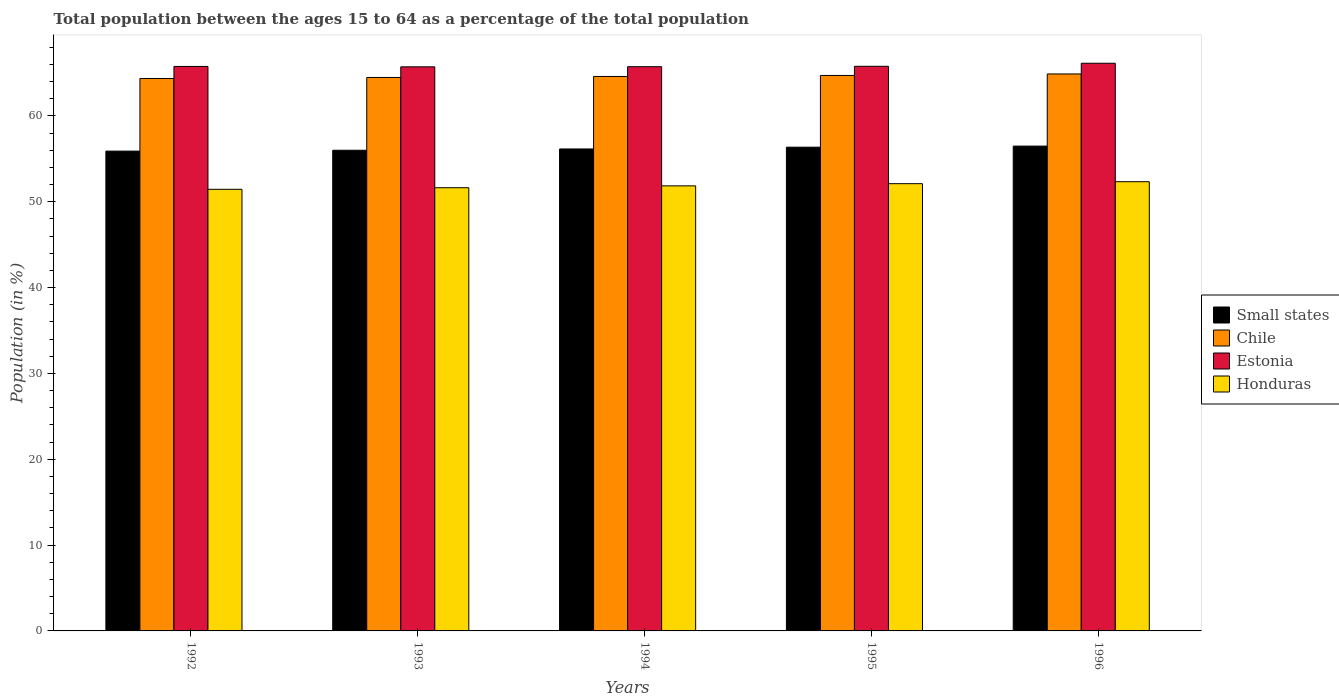How many different coloured bars are there?
Your answer should be compact. 4. How many bars are there on the 2nd tick from the left?
Your answer should be compact. 4. How many bars are there on the 2nd tick from the right?
Give a very brief answer. 4. In how many cases, is the number of bars for a given year not equal to the number of legend labels?
Your answer should be compact. 0. What is the percentage of the population ages 15 to 64 in Chile in 1996?
Make the answer very short. 64.89. Across all years, what is the maximum percentage of the population ages 15 to 64 in Estonia?
Offer a very short reply. 66.13. Across all years, what is the minimum percentage of the population ages 15 to 64 in Chile?
Provide a short and direct response. 64.36. In which year was the percentage of the population ages 15 to 64 in Chile maximum?
Your answer should be compact. 1996. What is the total percentage of the population ages 15 to 64 in Chile in the graph?
Provide a succinct answer. 323.04. What is the difference between the percentage of the population ages 15 to 64 in Chile in 1994 and that in 1996?
Keep it short and to the point. -0.29. What is the difference between the percentage of the population ages 15 to 64 in Estonia in 1992 and the percentage of the population ages 15 to 64 in Honduras in 1996?
Your answer should be very brief. 13.43. What is the average percentage of the population ages 15 to 64 in Small states per year?
Your answer should be compact. 56.18. In the year 1995, what is the difference between the percentage of the population ages 15 to 64 in Honduras and percentage of the population ages 15 to 64 in Chile?
Make the answer very short. -12.61. What is the ratio of the percentage of the population ages 15 to 64 in Chile in 1992 to that in 1996?
Ensure brevity in your answer.  0.99. Is the difference between the percentage of the population ages 15 to 64 in Honduras in 1992 and 1994 greater than the difference between the percentage of the population ages 15 to 64 in Chile in 1992 and 1994?
Provide a short and direct response. No. What is the difference between the highest and the second highest percentage of the population ages 15 to 64 in Honduras?
Your answer should be compact. 0.23. What is the difference between the highest and the lowest percentage of the population ages 15 to 64 in Estonia?
Your answer should be compact. 0.42. Is the sum of the percentage of the population ages 15 to 64 in Small states in 1995 and 1996 greater than the maximum percentage of the population ages 15 to 64 in Chile across all years?
Make the answer very short. Yes. Is it the case that in every year, the sum of the percentage of the population ages 15 to 64 in Chile and percentage of the population ages 15 to 64 in Small states is greater than the sum of percentage of the population ages 15 to 64 in Estonia and percentage of the population ages 15 to 64 in Honduras?
Provide a short and direct response. No. What does the 3rd bar from the left in 1994 represents?
Offer a very short reply. Estonia. What does the 4th bar from the right in 1992 represents?
Your response must be concise. Small states. Is it the case that in every year, the sum of the percentage of the population ages 15 to 64 in Honduras and percentage of the population ages 15 to 64 in Chile is greater than the percentage of the population ages 15 to 64 in Small states?
Your response must be concise. Yes. How many years are there in the graph?
Ensure brevity in your answer.  5. Does the graph contain grids?
Your answer should be very brief. No. How many legend labels are there?
Provide a short and direct response. 4. What is the title of the graph?
Offer a very short reply. Total population between the ages 15 to 64 as a percentage of the total population. What is the Population (in %) of Small states in 1992?
Make the answer very short. 55.9. What is the Population (in %) of Chile in 1992?
Ensure brevity in your answer.  64.36. What is the Population (in %) in Estonia in 1992?
Provide a short and direct response. 65.76. What is the Population (in %) in Honduras in 1992?
Provide a short and direct response. 51.45. What is the Population (in %) in Small states in 1993?
Keep it short and to the point. 56. What is the Population (in %) of Chile in 1993?
Give a very brief answer. 64.48. What is the Population (in %) in Estonia in 1993?
Give a very brief answer. 65.72. What is the Population (in %) of Honduras in 1993?
Your response must be concise. 51.63. What is the Population (in %) of Small states in 1994?
Keep it short and to the point. 56.15. What is the Population (in %) in Chile in 1994?
Provide a succinct answer. 64.6. What is the Population (in %) in Estonia in 1994?
Your response must be concise. 65.73. What is the Population (in %) of Honduras in 1994?
Offer a terse response. 51.85. What is the Population (in %) in Small states in 1995?
Provide a succinct answer. 56.36. What is the Population (in %) of Chile in 1995?
Offer a very short reply. 64.71. What is the Population (in %) in Estonia in 1995?
Make the answer very short. 65.78. What is the Population (in %) in Honduras in 1995?
Keep it short and to the point. 52.11. What is the Population (in %) in Small states in 1996?
Keep it short and to the point. 56.48. What is the Population (in %) of Chile in 1996?
Offer a very short reply. 64.89. What is the Population (in %) in Estonia in 1996?
Offer a terse response. 66.13. What is the Population (in %) in Honduras in 1996?
Ensure brevity in your answer.  52.34. Across all years, what is the maximum Population (in %) of Small states?
Your response must be concise. 56.48. Across all years, what is the maximum Population (in %) of Chile?
Offer a very short reply. 64.89. Across all years, what is the maximum Population (in %) of Estonia?
Offer a terse response. 66.13. Across all years, what is the maximum Population (in %) in Honduras?
Make the answer very short. 52.34. Across all years, what is the minimum Population (in %) in Small states?
Ensure brevity in your answer.  55.9. Across all years, what is the minimum Population (in %) in Chile?
Provide a succinct answer. 64.36. Across all years, what is the minimum Population (in %) in Estonia?
Keep it short and to the point. 65.72. Across all years, what is the minimum Population (in %) in Honduras?
Offer a very short reply. 51.45. What is the total Population (in %) in Small states in the graph?
Your answer should be compact. 280.89. What is the total Population (in %) in Chile in the graph?
Provide a succinct answer. 323.04. What is the total Population (in %) in Estonia in the graph?
Make the answer very short. 329.13. What is the total Population (in %) of Honduras in the graph?
Your answer should be very brief. 259.37. What is the difference between the Population (in %) of Small states in 1992 and that in 1993?
Provide a short and direct response. -0.1. What is the difference between the Population (in %) in Chile in 1992 and that in 1993?
Offer a very short reply. -0.12. What is the difference between the Population (in %) in Estonia in 1992 and that in 1993?
Offer a very short reply. 0.05. What is the difference between the Population (in %) of Honduras in 1992 and that in 1993?
Keep it short and to the point. -0.18. What is the difference between the Population (in %) in Small states in 1992 and that in 1994?
Keep it short and to the point. -0.25. What is the difference between the Population (in %) in Chile in 1992 and that in 1994?
Make the answer very short. -0.24. What is the difference between the Population (in %) of Estonia in 1992 and that in 1994?
Ensure brevity in your answer.  0.03. What is the difference between the Population (in %) of Honduras in 1992 and that in 1994?
Your answer should be compact. -0.4. What is the difference between the Population (in %) of Small states in 1992 and that in 1995?
Provide a short and direct response. -0.46. What is the difference between the Population (in %) of Chile in 1992 and that in 1995?
Your response must be concise. -0.35. What is the difference between the Population (in %) of Estonia in 1992 and that in 1995?
Offer a terse response. -0.02. What is the difference between the Population (in %) in Honduras in 1992 and that in 1995?
Ensure brevity in your answer.  -0.66. What is the difference between the Population (in %) in Small states in 1992 and that in 1996?
Offer a terse response. -0.58. What is the difference between the Population (in %) in Chile in 1992 and that in 1996?
Keep it short and to the point. -0.53. What is the difference between the Population (in %) of Estonia in 1992 and that in 1996?
Your response must be concise. -0.37. What is the difference between the Population (in %) of Honduras in 1992 and that in 1996?
Give a very brief answer. -0.89. What is the difference between the Population (in %) in Small states in 1993 and that in 1994?
Provide a short and direct response. -0.15. What is the difference between the Population (in %) in Chile in 1993 and that in 1994?
Keep it short and to the point. -0.12. What is the difference between the Population (in %) of Estonia in 1993 and that in 1994?
Provide a succinct answer. -0.02. What is the difference between the Population (in %) of Honduras in 1993 and that in 1994?
Provide a short and direct response. -0.22. What is the difference between the Population (in %) of Small states in 1993 and that in 1995?
Ensure brevity in your answer.  -0.36. What is the difference between the Population (in %) in Chile in 1993 and that in 1995?
Make the answer very short. -0.24. What is the difference between the Population (in %) of Estonia in 1993 and that in 1995?
Give a very brief answer. -0.06. What is the difference between the Population (in %) of Honduras in 1993 and that in 1995?
Your answer should be compact. -0.47. What is the difference between the Population (in %) in Small states in 1993 and that in 1996?
Keep it short and to the point. -0.48. What is the difference between the Population (in %) in Chile in 1993 and that in 1996?
Offer a very short reply. -0.41. What is the difference between the Population (in %) of Estonia in 1993 and that in 1996?
Keep it short and to the point. -0.42. What is the difference between the Population (in %) in Honduras in 1993 and that in 1996?
Ensure brevity in your answer.  -0.7. What is the difference between the Population (in %) in Small states in 1994 and that in 1995?
Offer a very short reply. -0.21. What is the difference between the Population (in %) in Chile in 1994 and that in 1995?
Give a very brief answer. -0.12. What is the difference between the Population (in %) in Estonia in 1994 and that in 1995?
Provide a succinct answer. -0.05. What is the difference between the Population (in %) of Honduras in 1994 and that in 1995?
Give a very brief answer. -0.26. What is the difference between the Population (in %) in Small states in 1994 and that in 1996?
Your answer should be compact. -0.33. What is the difference between the Population (in %) of Chile in 1994 and that in 1996?
Your answer should be compact. -0.29. What is the difference between the Population (in %) in Estonia in 1994 and that in 1996?
Provide a short and direct response. -0.4. What is the difference between the Population (in %) of Honduras in 1994 and that in 1996?
Offer a terse response. -0.49. What is the difference between the Population (in %) in Small states in 1995 and that in 1996?
Keep it short and to the point. -0.13. What is the difference between the Population (in %) in Chile in 1995 and that in 1996?
Provide a succinct answer. -0.17. What is the difference between the Population (in %) in Estonia in 1995 and that in 1996?
Your response must be concise. -0.35. What is the difference between the Population (in %) of Honduras in 1995 and that in 1996?
Your response must be concise. -0.23. What is the difference between the Population (in %) in Small states in 1992 and the Population (in %) in Chile in 1993?
Your response must be concise. -8.58. What is the difference between the Population (in %) of Small states in 1992 and the Population (in %) of Estonia in 1993?
Make the answer very short. -9.82. What is the difference between the Population (in %) of Small states in 1992 and the Population (in %) of Honduras in 1993?
Make the answer very short. 4.27. What is the difference between the Population (in %) of Chile in 1992 and the Population (in %) of Estonia in 1993?
Give a very brief answer. -1.36. What is the difference between the Population (in %) in Chile in 1992 and the Population (in %) in Honduras in 1993?
Give a very brief answer. 12.73. What is the difference between the Population (in %) in Estonia in 1992 and the Population (in %) in Honduras in 1993?
Provide a succinct answer. 14.13. What is the difference between the Population (in %) in Small states in 1992 and the Population (in %) in Chile in 1994?
Give a very brief answer. -8.7. What is the difference between the Population (in %) of Small states in 1992 and the Population (in %) of Estonia in 1994?
Provide a short and direct response. -9.84. What is the difference between the Population (in %) in Small states in 1992 and the Population (in %) in Honduras in 1994?
Provide a short and direct response. 4.05. What is the difference between the Population (in %) of Chile in 1992 and the Population (in %) of Estonia in 1994?
Ensure brevity in your answer.  -1.37. What is the difference between the Population (in %) of Chile in 1992 and the Population (in %) of Honduras in 1994?
Make the answer very short. 12.51. What is the difference between the Population (in %) of Estonia in 1992 and the Population (in %) of Honduras in 1994?
Your answer should be very brief. 13.91. What is the difference between the Population (in %) in Small states in 1992 and the Population (in %) in Chile in 1995?
Make the answer very short. -8.81. What is the difference between the Population (in %) of Small states in 1992 and the Population (in %) of Estonia in 1995?
Provide a short and direct response. -9.88. What is the difference between the Population (in %) of Small states in 1992 and the Population (in %) of Honduras in 1995?
Provide a succinct answer. 3.79. What is the difference between the Population (in %) in Chile in 1992 and the Population (in %) in Estonia in 1995?
Give a very brief answer. -1.42. What is the difference between the Population (in %) of Chile in 1992 and the Population (in %) of Honduras in 1995?
Ensure brevity in your answer.  12.25. What is the difference between the Population (in %) of Estonia in 1992 and the Population (in %) of Honduras in 1995?
Your answer should be compact. 13.66. What is the difference between the Population (in %) of Small states in 1992 and the Population (in %) of Chile in 1996?
Offer a terse response. -8.99. What is the difference between the Population (in %) in Small states in 1992 and the Population (in %) in Estonia in 1996?
Offer a terse response. -10.24. What is the difference between the Population (in %) of Small states in 1992 and the Population (in %) of Honduras in 1996?
Your response must be concise. 3.56. What is the difference between the Population (in %) of Chile in 1992 and the Population (in %) of Estonia in 1996?
Your answer should be compact. -1.77. What is the difference between the Population (in %) in Chile in 1992 and the Population (in %) in Honduras in 1996?
Offer a terse response. 12.02. What is the difference between the Population (in %) of Estonia in 1992 and the Population (in %) of Honduras in 1996?
Your answer should be very brief. 13.43. What is the difference between the Population (in %) in Small states in 1993 and the Population (in %) in Chile in 1994?
Provide a succinct answer. -8.6. What is the difference between the Population (in %) of Small states in 1993 and the Population (in %) of Estonia in 1994?
Provide a succinct answer. -9.74. What is the difference between the Population (in %) in Small states in 1993 and the Population (in %) in Honduras in 1994?
Your answer should be very brief. 4.15. What is the difference between the Population (in %) in Chile in 1993 and the Population (in %) in Estonia in 1994?
Your answer should be compact. -1.26. What is the difference between the Population (in %) of Chile in 1993 and the Population (in %) of Honduras in 1994?
Offer a terse response. 12.63. What is the difference between the Population (in %) of Estonia in 1993 and the Population (in %) of Honduras in 1994?
Keep it short and to the point. 13.87. What is the difference between the Population (in %) of Small states in 1993 and the Population (in %) of Chile in 1995?
Your response must be concise. -8.71. What is the difference between the Population (in %) in Small states in 1993 and the Population (in %) in Estonia in 1995?
Provide a succinct answer. -9.78. What is the difference between the Population (in %) in Small states in 1993 and the Population (in %) in Honduras in 1995?
Ensure brevity in your answer.  3.89. What is the difference between the Population (in %) in Chile in 1993 and the Population (in %) in Estonia in 1995?
Your answer should be compact. -1.3. What is the difference between the Population (in %) of Chile in 1993 and the Population (in %) of Honduras in 1995?
Offer a terse response. 12.37. What is the difference between the Population (in %) in Estonia in 1993 and the Population (in %) in Honduras in 1995?
Make the answer very short. 13.61. What is the difference between the Population (in %) of Small states in 1993 and the Population (in %) of Chile in 1996?
Your answer should be very brief. -8.89. What is the difference between the Population (in %) of Small states in 1993 and the Population (in %) of Estonia in 1996?
Provide a short and direct response. -10.14. What is the difference between the Population (in %) in Small states in 1993 and the Population (in %) in Honduras in 1996?
Your answer should be very brief. 3.66. What is the difference between the Population (in %) in Chile in 1993 and the Population (in %) in Estonia in 1996?
Provide a succinct answer. -1.66. What is the difference between the Population (in %) of Chile in 1993 and the Population (in %) of Honduras in 1996?
Provide a short and direct response. 12.14. What is the difference between the Population (in %) of Estonia in 1993 and the Population (in %) of Honduras in 1996?
Your response must be concise. 13.38. What is the difference between the Population (in %) in Small states in 1994 and the Population (in %) in Chile in 1995?
Your response must be concise. -8.56. What is the difference between the Population (in %) of Small states in 1994 and the Population (in %) of Estonia in 1995?
Your answer should be compact. -9.63. What is the difference between the Population (in %) of Small states in 1994 and the Population (in %) of Honduras in 1995?
Provide a succinct answer. 4.04. What is the difference between the Population (in %) of Chile in 1994 and the Population (in %) of Estonia in 1995?
Offer a terse response. -1.18. What is the difference between the Population (in %) of Chile in 1994 and the Population (in %) of Honduras in 1995?
Give a very brief answer. 12.49. What is the difference between the Population (in %) in Estonia in 1994 and the Population (in %) in Honduras in 1995?
Your answer should be compact. 13.63. What is the difference between the Population (in %) in Small states in 1994 and the Population (in %) in Chile in 1996?
Provide a succinct answer. -8.74. What is the difference between the Population (in %) in Small states in 1994 and the Population (in %) in Estonia in 1996?
Offer a terse response. -9.98. What is the difference between the Population (in %) in Small states in 1994 and the Population (in %) in Honduras in 1996?
Offer a terse response. 3.81. What is the difference between the Population (in %) of Chile in 1994 and the Population (in %) of Estonia in 1996?
Give a very brief answer. -1.54. What is the difference between the Population (in %) of Chile in 1994 and the Population (in %) of Honduras in 1996?
Provide a short and direct response. 12.26. What is the difference between the Population (in %) of Estonia in 1994 and the Population (in %) of Honduras in 1996?
Provide a short and direct response. 13.4. What is the difference between the Population (in %) in Small states in 1995 and the Population (in %) in Chile in 1996?
Your response must be concise. -8.53. What is the difference between the Population (in %) in Small states in 1995 and the Population (in %) in Estonia in 1996?
Offer a terse response. -9.78. What is the difference between the Population (in %) in Small states in 1995 and the Population (in %) in Honduras in 1996?
Provide a short and direct response. 4.02. What is the difference between the Population (in %) in Chile in 1995 and the Population (in %) in Estonia in 1996?
Provide a short and direct response. -1.42. What is the difference between the Population (in %) in Chile in 1995 and the Population (in %) in Honduras in 1996?
Ensure brevity in your answer.  12.38. What is the difference between the Population (in %) in Estonia in 1995 and the Population (in %) in Honduras in 1996?
Your answer should be compact. 13.44. What is the average Population (in %) of Small states per year?
Keep it short and to the point. 56.18. What is the average Population (in %) in Chile per year?
Your response must be concise. 64.61. What is the average Population (in %) of Estonia per year?
Provide a succinct answer. 65.83. What is the average Population (in %) in Honduras per year?
Offer a terse response. 51.87. In the year 1992, what is the difference between the Population (in %) in Small states and Population (in %) in Chile?
Your answer should be compact. -8.46. In the year 1992, what is the difference between the Population (in %) in Small states and Population (in %) in Estonia?
Your answer should be very brief. -9.86. In the year 1992, what is the difference between the Population (in %) in Small states and Population (in %) in Honduras?
Give a very brief answer. 4.45. In the year 1992, what is the difference between the Population (in %) of Chile and Population (in %) of Estonia?
Give a very brief answer. -1.4. In the year 1992, what is the difference between the Population (in %) of Chile and Population (in %) of Honduras?
Make the answer very short. 12.91. In the year 1992, what is the difference between the Population (in %) in Estonia and Population (in %) in Honduras?
Your answer should be compact. 14.31. In the year 1993, what is the difference between the Population (in %) of Small states and Population (in %) of Chile?
Give a very brief answer. -8.48. In the year 1993, what is the difference between the Population (in %) in Small states and Population (in %) in Estonia?
Keep it short and to the point. -9.72. In the year 1993, what is the difference between the Population (in %) of Small states and Population (in %) of Honduras?
Provide a succinct answer. 4.37. In the year 1993, what is the difference between the Population (in %) in Chile and Population (in %) in Estonia?
Provide a short and direct response. -1.24. In the year 1993, what is the difference between the Population (in %) of Chile and Population (in %) of Honduras?
Your answer should be compact. 12.85. In the year 1993, what is the difference between the Population (in %) of Estonia and Population (in %) of Honduras?
Offer a terse response. 14.09. In the year 1994, what is the difference between the Population (in %) in Small states and Population (in %) in Chile?
Give a very brief answer. -8.45. In the year 1994, what is the difference between the Population (in %) in Small states and Population (in %) in Estonia?
Offer a very short reply. -9.58. In the year 1994, what is the difference between the Population (in %) in Small states and Population (in %) in Honduras?
Give a very brief answer. 4.3. In the year 1994, what is the difference between the Population (in %) in Chile and Population (in %) in Estonia?
Keep it short and to the point. -1.14. In the year 1994, what is the difference between the Population (in %) of Chile and Population (in %) of Honduras?
Your answer should be very brief. 12.75. In the year 1994, what is the difference between the Population (in %) of Estonia and Population (in %) of Honduras?
Keep it short and to the point. 13.88. In the year 1995, what is the difference between the Population (in %) of Small states and Population (in %) of Chile?
Offer a terse response. -8.36. In the year 1995, what is the difference between the Population (in %) in Small states and Population (in %) in Estonia?
Make the answer very short. -9.42. In the year 1995, what is the difference between the Population (in %) of Small states and Population (in %) of Honduras?
Your response must be concise. 4.25. In the year 1995, what is the difference between the Population (in %) of Chile and Population (in %) of Estonia?
Provide a short and direct response. -1.07. In the year 1995, what is the difference between the Population (in %) of Chile and Population (in %) of Honduras?
Your answer should be compact. 12.61. In the year 1995, what is the difference between the Population (in %) in Estonia and Population (in %) in Honduras?
Provide a short and direct response. 13.67. In the year 1996, what is the difference between the Population (in %) of Small states and Population (in %) of Chile?
Ensure brevity in your answer.  -8.4. In the year 1996, what is the difference between the Population (in %) in Small states and Population (in %) in Estonia?
Provide a succinct answer. -9.65. In the year 1996, what is the difference between the Population (in %) in Small states and Population (in %) in Honduras?
Offer a terse response. 4.15. In the year 1996, what is the difference between the Population (in %) of Chile and Population (in %) of Estonia?
Your answer should be very brief. -1.25. In the year 1996, what is the difference between the Population (in %) of Chile and Population (in %) of Honduras?
Your answer should be compact. 12.55. In the year 1996, what is the difference between the Population (in %) in Estonia and Population (in %) in Honduras?
Provide a succinct answer. 13.8. What is the ratio of the Population (in %) in Small states in 1992 to that in 1993?
Offer a very short reply. 1. What is the ratio of the Population (in %) in Chile in 1992 to that in 1993?
Give a very brief answer. 1. What is the ratio of the Population (in %) of Small states in 1992 to that in 1994?
Offer a terse response. 1. What is the ratio of the Population (in %) of Chile in 1992 to that in 1994?
Your response must be concise. 1. What is the ratio of the Population (in %) in Estonia in 1992 to that in 1995?
Keep it short and to the point. 1. What is the ratio of the Population (in %) in Honduras in 1992 to that in 1995?
Make the answer very short. 0.99. What is the ratio of the Population (in %) of Honduras in 1992 to that in 1996?
Your answer should be very brief. 0.98. What is the ratio of the Population (in %) of Small states in 1993 to that in 1994?
Provide a succinct answer. 1. What is the ratio of the Population (in %) in Chile in 1993 to that in 1994?
Your response must be concise. 1. What is the ratio of the Population (in %) of Honduras in 1993 to that in 1994?
Provide a short and direct response. 1. What is the ratio of the Population (in %) of Small states in 1993 to that in 1995?
Ensure brevity in your answer.  0.99. What is the ratio of the Population (in %) of Estonia in 1993 to that in 1995?
Give a very brief answer. 1. What is the ratio of the Population (in %) in Honduras in 1993 to that in 1995?
Keep it short and to the point. 0.99. What is the ratio of the Population (in %) in Chile in 1993 to that in 1996?
Ensure brevity in your answer.  0.99. What is the ratio of the Population (in %) in Honduras in 1993 to that in 1996?
Keep it short and to the point. 0.99. What is the ratio of the Population (in %) in Small states in 1994 to that in 1995?
Provide a succinct answer. 1. What is the ratio of the Population (in %) of Chile in 1994 to that in 1995?
Provide a short and direct response. 1. What is the ratio of the Population (in %) of Estonia in 1994 to that in 1995?
Give a very brief answer. 1. What is the ratio of the Population (in %) in Honduras in 1994 to that in 1995?
Your response must be concise. 1. What is the ratio of the Population (in %) in Small states in 1994 to that in 1996?
Keep it short and to the point. 0.99. What is the ratio of the Population (in %) in Chile in 1994 to that in 1996?
Provide a succinct answer. 1. What is the ratio of the Population (in %) of Estonia in 1994 to that in 1996?
Make the answer very short. 0.99. What is the ratio of the Population (in %) of Small states in 1995 to that in 1996?
Your answer should be very brief. 1. What is the ratio of the Population (in %) of Chile in 1995 to that in 1996?
Ensure brevity in your answer.  1. What is the ratio of the Population (in %) of Estonia in 1995 to that in 1996?
Offer a terse response. 0.99. What is the difference between the highest and the second highest Population (in %) of Small states?
Make the answer very short. 0.13. What is the difference between the highest and the second highest Population (in %) in Chile?
Offer a terse response. 0.17. What is the difference between the highest and the second highest Population (in %) of Estonia?
Offer a terse response. 0.35. What is the difference between the highest and the second highest Population (in %) of Honduras?
Offer a terse response. 0.23. What is the difference between the highest and the lowest Population (in %) of Small states?
Your answer should be very brief. 0.58. What is the difference between the highest and the lowest Population (in %) in Chile?
Make the answer very short. 0.53. What is the difference between the highest and the lowest Population (in %) of Estonia?
Make the answer very short. 0.42. What is the difference between the highest and the lowest Population (in %) in Honduras?
Your response must be concise. 0.89. 